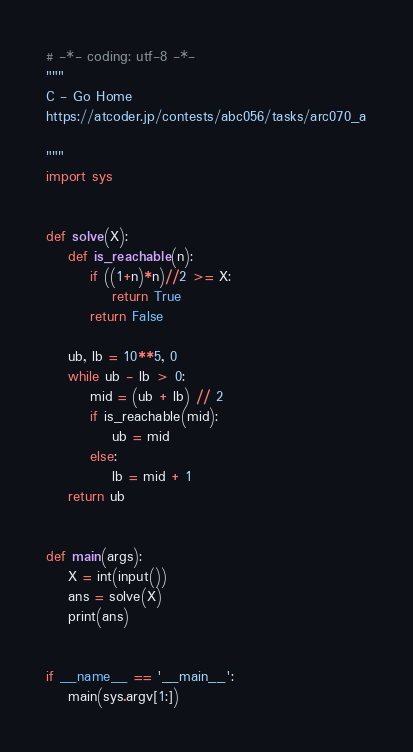<code> <loc_0><loc_0><loc_500><loc_500><_Python_># -*- coding: utf-8 -*-
"""
C - Go Home
https://atcoder.jp/contests/abc056/tasks/arc070_a

"""
import sys


def solve(X):
    def is_reachable(n):
        if ((1+n)*n)//2 >= X:
            return True
        return False

    ub, lb = 10**5, 0
    while ub - lb > 0:
        mid = (ub + lb) // 2
        if is_reachable(mid):
            ub = mid
        else:
            lb = mid + 1
    return ub


def main(args):
    X = int(input())
    ans = solve(X)
    print(ans)


if __name__ == '__main__':
    main(sys.argv[1:])
</code> 